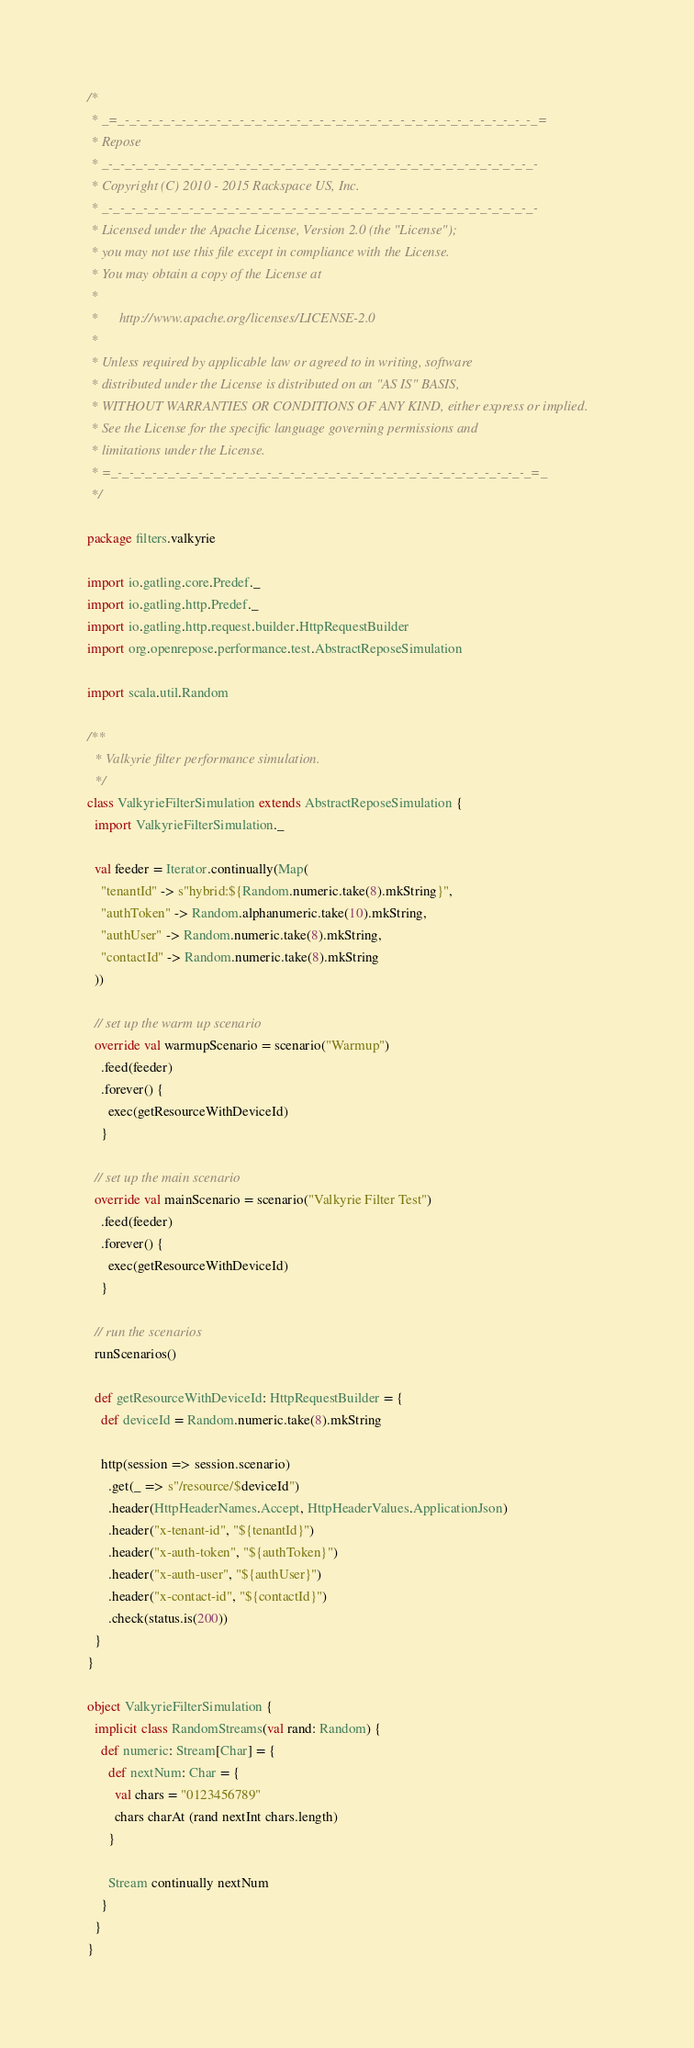Convert code to text. <code><loc_0><loc_0><loc_500><loc_500><_Scala_>/*
 * _=_-_-_-_-_-_-_-_-_-_-_-_-_-_-_-_-_-_-_-_-_-_-_-_-_-_-_-_-_-_-_-_-_-_-_-_-_=
 * Repose
 * _-_-_-_-_-_-_-_-_-_-_-_-_-_-_-_-_-_-_-_-_-_-_-_-_-_-_-_-_-_-_-_-_-_-_-_-_-_-
 * Copyright (C) 2010 - 2015 Rackspace US, Inc.
 * _-_-_-_-_-_-_-_-_-_-_-_-_-_-_-_-_-_-_-_-_-_-_-_-_-_-_-_-_-_-_-_-_-_-_-_-_-_-
 * Licensed under the Apache License, Version 2.0 (the "License");
 * you may not use this file except in compliance with the License.
 * You may obtain a copy of the License at
 *
 *      http://www.apache.org/licenses/LICENSE-2.0
 *
 * Unless required by applicable law or agreed to in writing, software
 * distributed under the License is distributed on an "AS IS" BASIS,
 * WITHOUT WARRANTIES OR CONDITIONS OF ANY KIND, either express or implied.
 * See the License for the specific language governing permissions and
 * limitations under the License.
 * =_-_-_-_-_-_-_-_-_-_-_-_-_-_-_-_-_-_-_-_-_-_-_-_-_-_-_-_-_-_-_-_-_-_-_-_-_=_
 */

package filters.valkyrie

import io.gatling.core.Predef._
import io.gatling.http.Predef._
import io.gatling.http.request.builder.HttpRequestBuilder
import org.openrepose.performance.test.AbstractReposeSimulation

import scala.util.Random

/**
  * Valkyrie filter performance simulation.
  */
class ValkyrieFilterSimulation extends AbstractReposeSimulation {
  import ValkyrieFilterSimulation._

  val feeder = Iterator.continually(Map(
    "tenantId" -> s"hybrid:${Random.numeric.take(8).mkString}",
    "authToken" -> Random.alphanumeric.take(10).mkString,
    "authUser" -> Random.numeric.take(8).mkString,
    "contactId" -> Random.numeric.take(8).mkString
  ))

  // set up the warm up scenario
  override val warmupScenario = scenario("Warmup")
    .feed(feeder)
    .forever() {
      exec(getResourceWithDeviceId)
    }

  // set up the main scenario
  override val mainScenario = scenario("Valkyrie Filter Test")
    .feed(feeder)
    .forever() {
      exec(getResourceWithDeviceId)
    }

  // run the scenarios
  runScenarios()

  def getResourceWithDeviceId: HttpRequestBuilder = {
    def deviceId = Random.numeric.take(8).mkString

    http(session => session.scenario)
      .get(_ => s"/resource/$deviceId")
      .header(HttpHeaderNames.Accept, HttpHeaderValues.ApplicationJson)
      .header("x-tenant-id", "${tenantId}")
      .header("x-auth-token", "${authToken}")
      .header("x-auth-user", "${authUser}")
      .header("x-contact-id", "${contactId}")
      .check(status.is(200))
  }
}

object ValkyrieFilterSimulation {
  implicit class RandomStreams(val rand: Random) {
    def numeric: Stream[Char] = {
      def nextNum: Char = {
        val chars = "0123456789"
        chars charAt (rand nextInt chars.length)
      }

      Stream continually nextNum
    }
  }
}
</code> 